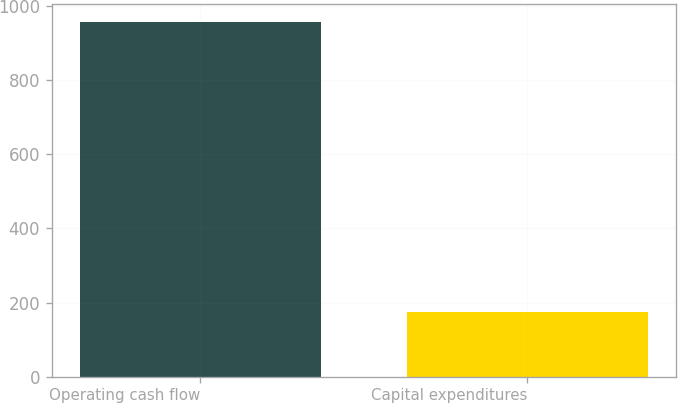Convert chart. <chart><loc_0><loc_0><loc_500><loc_500><bar_chart><fcel>Operating cash flow<fcel>Capital expenditures<nl><fcel>958<fcel>175<nl></chart> 